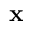<formula> <loc_0><loc_0><loc_500><loc_500>x</formula> 